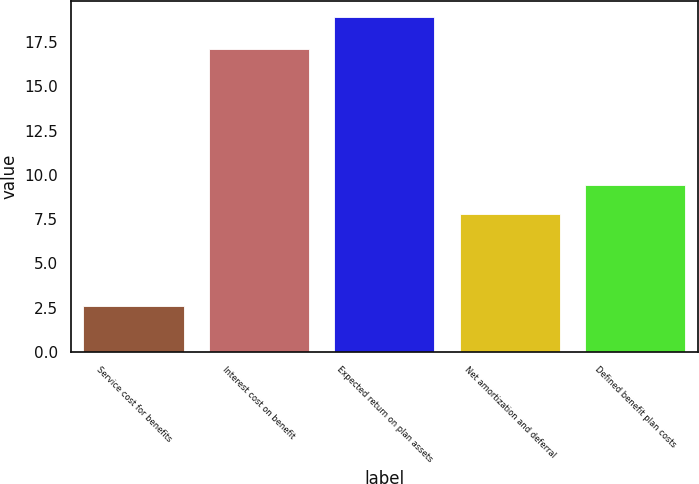<chart> <loc_0><loc_0><loc_500><loc_500><bar_chart><fcel>Service cost for benefits<fcel>Interest cost on benefit<fcel>Expected return on plan assets<fcel>Net amortization and deferral<fcel>Defined benefit plan costs<nl><fcel>2.6<fcel>17.1<fcel>18.9<fcel>7.8<fcel>9.43<nl></chart> 